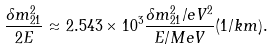Convert formula to latex. <formula><loc_0><loc_0><loc_500><loc_500>\frac { \delta m ^ { 2 } _ { 2 1 } } { 2 E } \approx 2 . 5 4 3 \times 1 0 ^ { 3 } \frac { \delta m ^ { 2 } _ { 2 1 } / e V ^ { 2 } } { E / M e V } ( 1 / k m ) .</formula> 